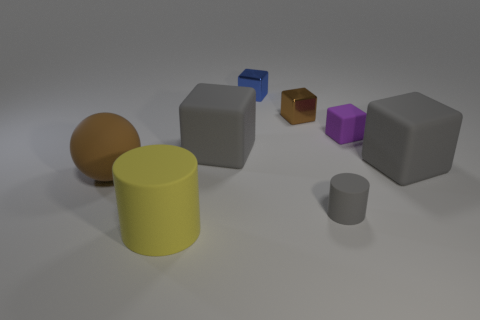Add 1 yellow cylinders. How many objects exist? 9 Subtract all gray matte blocks. How many blocks are left? 3 Subtract all gray spheres. How many gray cubes are left? 2 Subtract all purple blocks. How many blocks are left? 4 Add 6 large spheres. How many large spheres are left? 7 Add 5 blue cubes. How many blue cubes exist? 6 Subtract 0 red cylinders. How many objects are left? 8 Subtract all balls. How many objects are left? 7 Subtract all brown blocks. Subtract all red cylinders. How many blocks are left? 4 Subtract all tiny metal objects. Subtract all big gray rubber objects. How many objects are left? 4 